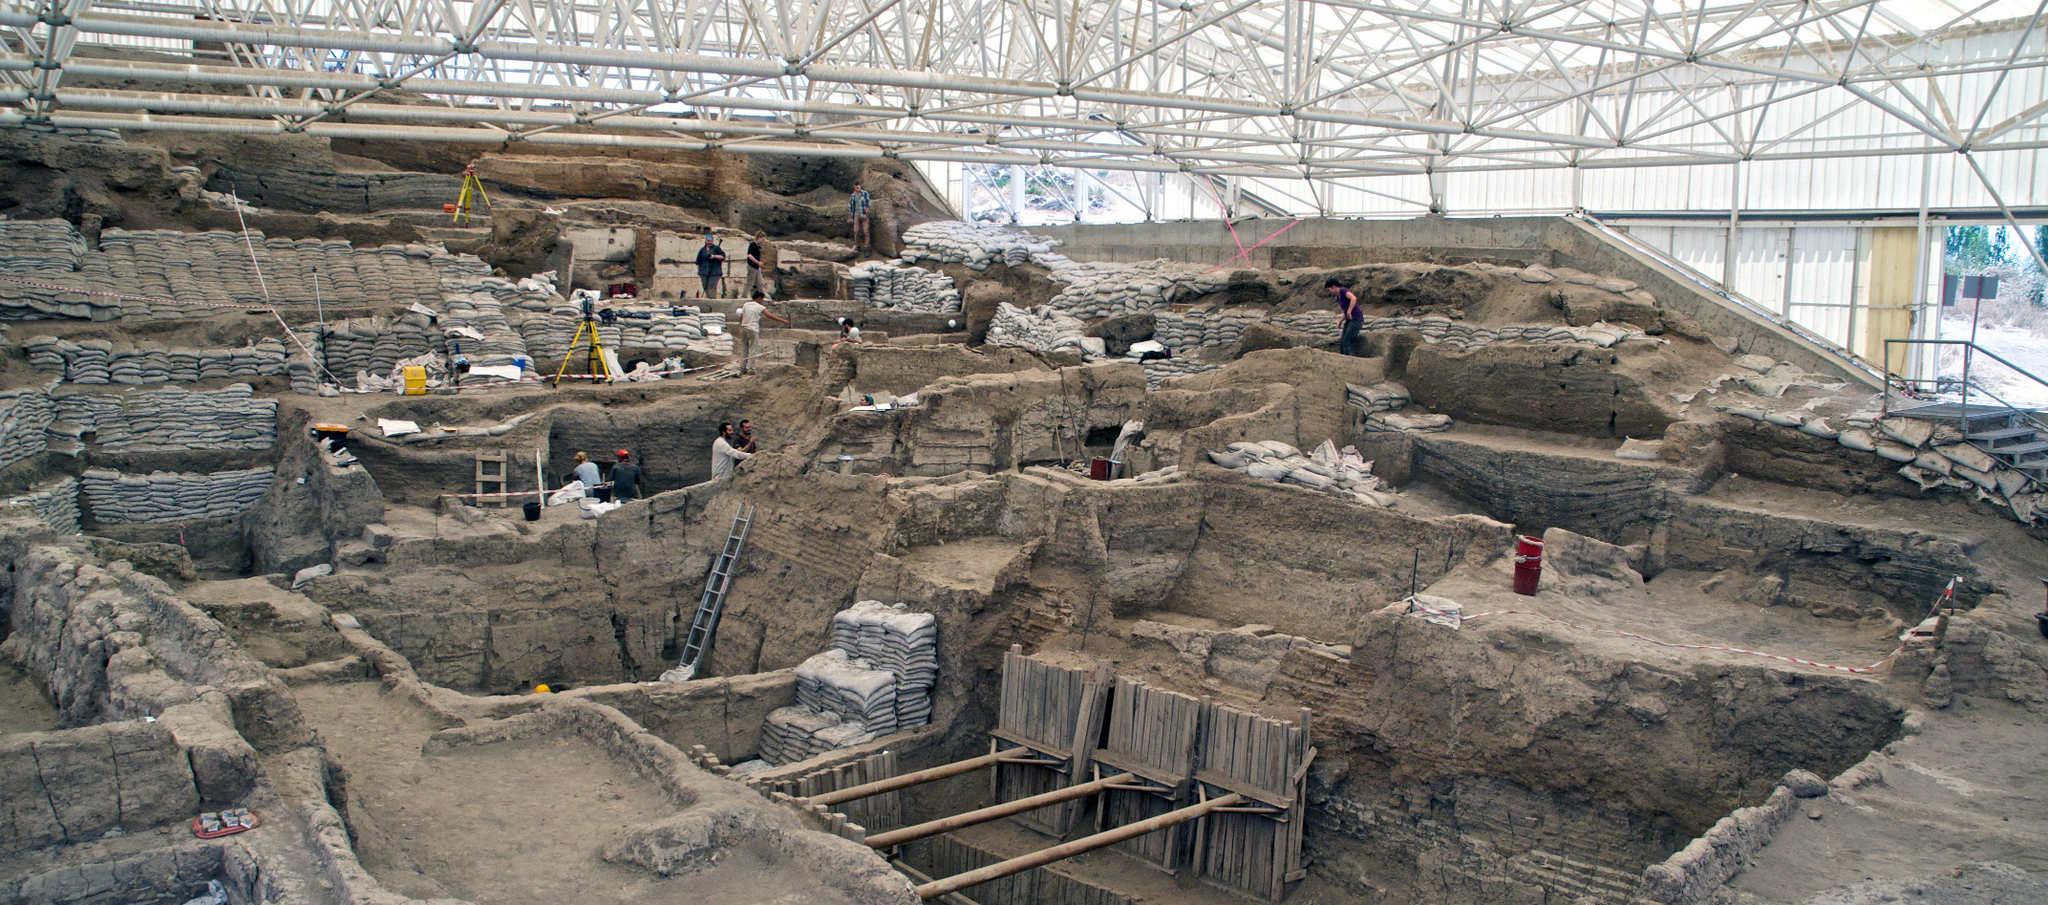What ancient secrets might be hidden within the depths of this archaeological site? The archaeological site of Çatalhöyük holds many secrets of early human civilization. Among the ruins, archaeologists have uncovered well-preserved remnants of dwellings, tools, and artifacts that provide a window into the daily lives of its ancient inhabitants. We might find more intricate murals, burial sites with hidden rituals, or sophisticated tools that reveal advanced levels of craftsmanship and societal organization. The deeper excavations might even present evidence of early forms of writing or unprecedented technological innovations, offering new chapters to the story of human development. How do archaeologists ensure the preservation of such a vast and ancient site while excavating it? Preserving an ancient site like Çatalhöyük while excavating it involves meticulous planning and the use of specialized techniques. The erected roof structure protects the site from environmental factors like rain and sun exposure. Archaeologists use tools like brushes and small trowels to carefully remove soil around delicate artifacts. Areas of interest are documented extensively through photographs, sketches, and digital recordings before and during excavation. Additionally, they use wooden scaffolding to stabilize certain sections and prevent collapses. Conservation experts often work alongside archaeologists to address the preservation needs of uncovered structures and artifacts immediately. Imagine if one of the rooms in the ruins was suddenly restored to its original state. Describe what you might see and experience inside. If one of the rooms in Çatalhöyük were magically restored to its original state, stepping inside would transport you back thousands of years. You might see intricately decorated walls adorned with vibrant frescoes depicting scenes of daily life, animals, and spiritual imagery. The room could be furnished with primitive yet functional wooden furniture, woven mats on the floor, and clay pots filled with grains or water. A central hearth would likely serve as the focal point for cooking and warmth, casting a comforting glow. The air might be filled with the earthy scent of clay and herbs, mingling with a faint hint of smoke from the hearth. Various tools and household items would lay scattered around, providing insights into the activities that once took place here. The overall ambiance would be one of communal living, with a deep connection to both family and the greater community. 